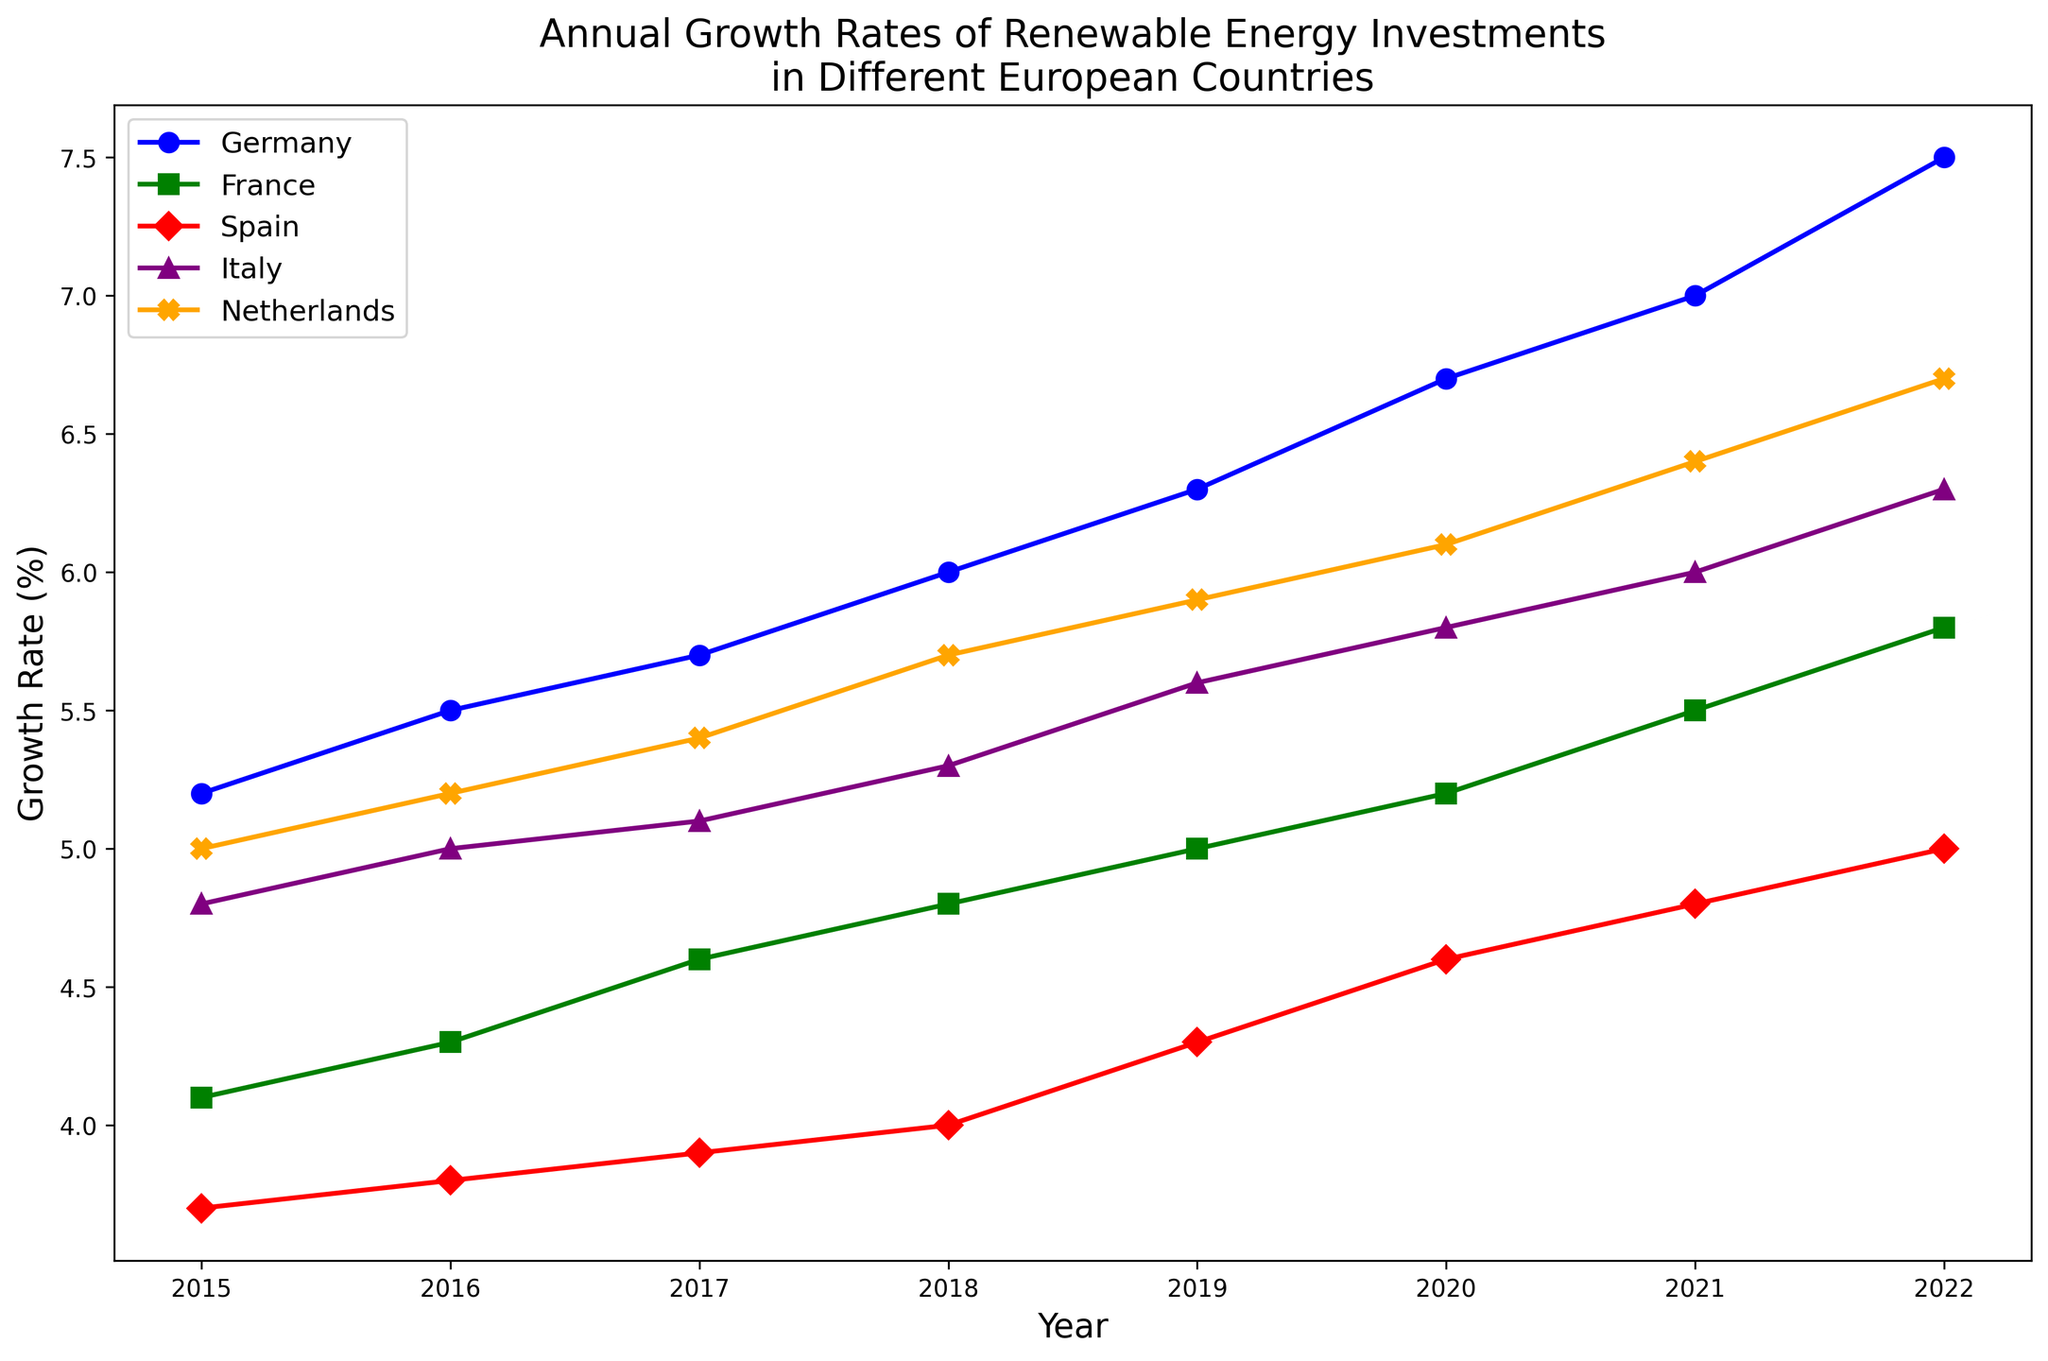What was the growth rate of renewable energy investments in Germany in 2021? Locate the line representing Germany (blue with 'o' markers). Find the point on the curve corresponding to the year 2021. The growth rate is indicated by the y-axis value at this point.
Answer: 7.0% Which country had the highest growth rate of renewable energy investments in 2022? Compare the end points of all lines (2022) to determine which had the highest y-axis value. Germany (blue line) reaches the highest point in 2022.
Answer: Germany How did the growth rate of renewable energy investments in Spain change from 2015 to 2019? Follow the red line with 'D' markers from 2015 to 2019. Note the y-axis values at these points, which indicate a consistent increase from 3.7% in 2015 to 4.3% in 2019.
Answer: Increased from 3.7% to 4.3% What is the average growth rate of renewable energy investments for Italy from 2018 to 2021? Locate Italy (purple with '^' markers) on the plot. Note the y-axis values from 2018 to 2021 (5.3%, 5.6%, 5.8%, 6.0%). Sum these values and divide by 4 (the number of years). Calculation: (5.3+5.6+5.8+6.0)/4 = 5.675.
Answer: 5.675% In 2020, which country had the smallest growth rate of renewable energy investments? Compare all countries' points on the graph at 2020, finding the lowest y-axis value. Spain (red line) has the lowest value at 4.6%.
Answer: Spain By how much did the growth rate of renewable energy investments in the Netherlands increase from 2015 to 2022? Find the growth rate for the Netherlands (orange line with 'X' markers) in 2015 and 2022 and subtract the former from the latter. Calculation: 6.7% - 5.0% = 1.7%.
Answer: 1.7% Which country's growth rate showed a consistent increase every year from 2015 to 2022? Examine each line to see which one consistently ascends without any drop each year. The blue line representing Germany shows a consistent increase.
Answer: Germany Comparing France and Italy, which country had a higher average growth rate from 2015 to 2022? Calculate the average yearly growth rates for France (green line with 's' markers) and Italy (purple line with '^' markers), then compare. France: (4.1+4.3+4.6+4.8+5.0+5.2+5.5+5.8)/8 = 4.925%. Italy: (4.8+5.0+5.1+5.3+5.6+5.8+6.0+6.3)/8 = 5.3625%.
Answer: Italy Identify the trend of renewable energy investments in France from 2015 to 2022. Follow the green line with 's' markers from 2015 to 2022. Note the consistent annual increase in the growth rate, indicating an upward trend.
Answer: Increasing Which country's growth rate remained relatively stable throughout the years? Look for a line that shows minimal fluctuation year over year. The red line representing Spain fluctuates the least.
Answer: Spain 